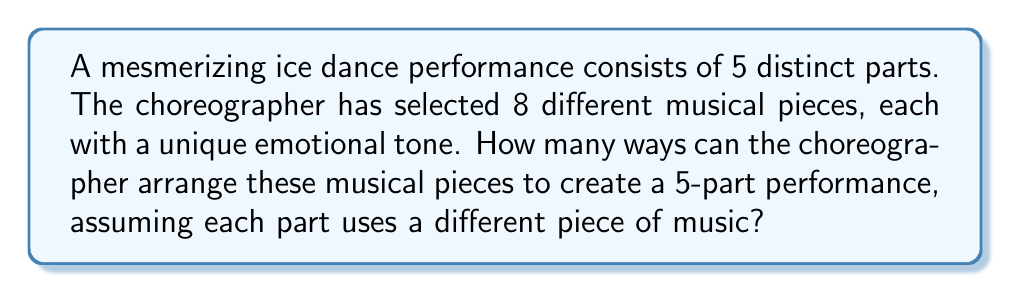Could you help me with this problem? To solve this problem, we need to use the concept of permutations. We are selecting 5 musical pieces out of 8 available pieces, and the order matters (as it affects the emotional journey of the performance).

1) This scenario is a perfect example of a permutation without repetition, as we are selecting 5 items from 8 without replacement and the order matters.

2) The formula for permutations without repetition is:

   $$P(n,r) = \frac{n!}{(n-r)!}$$

   Where $n$ is the total number of items to choose from, and $r$ is the number of items being chosen.

3) In this case, $n = 8$ (total musical pieces) and $r = 5$ (parts in the performance).

4) Let's substitute these values into our formula:

   $$P(8,5) = \frac{8!}{(8-5)!} = \frac{8!}{3!}$$

5) Expand this:
   $$\frac{8 * 7 * 6 * 5 * 4 * 3!}{3!}$$

6) The $3!$ cancels out in the numerator and denominator:

   $$8 * 7 * 6 * 5 * 4 = 6720$$

Therefore, there are 6720 possible ways to arrange the musical pieces for the 5-part ice dance performance.
Answer: 6720 